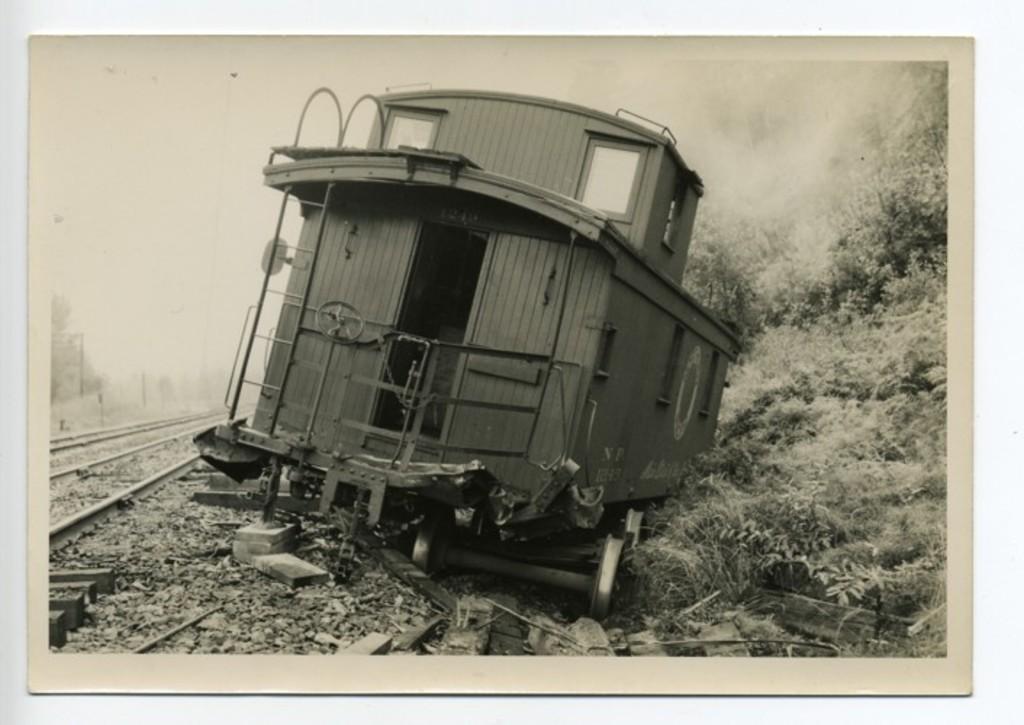Describe this image in one or two sentences. In this image I can see few railway tracks, grass and here I can see a train. I can see this image is black and white in colour. 